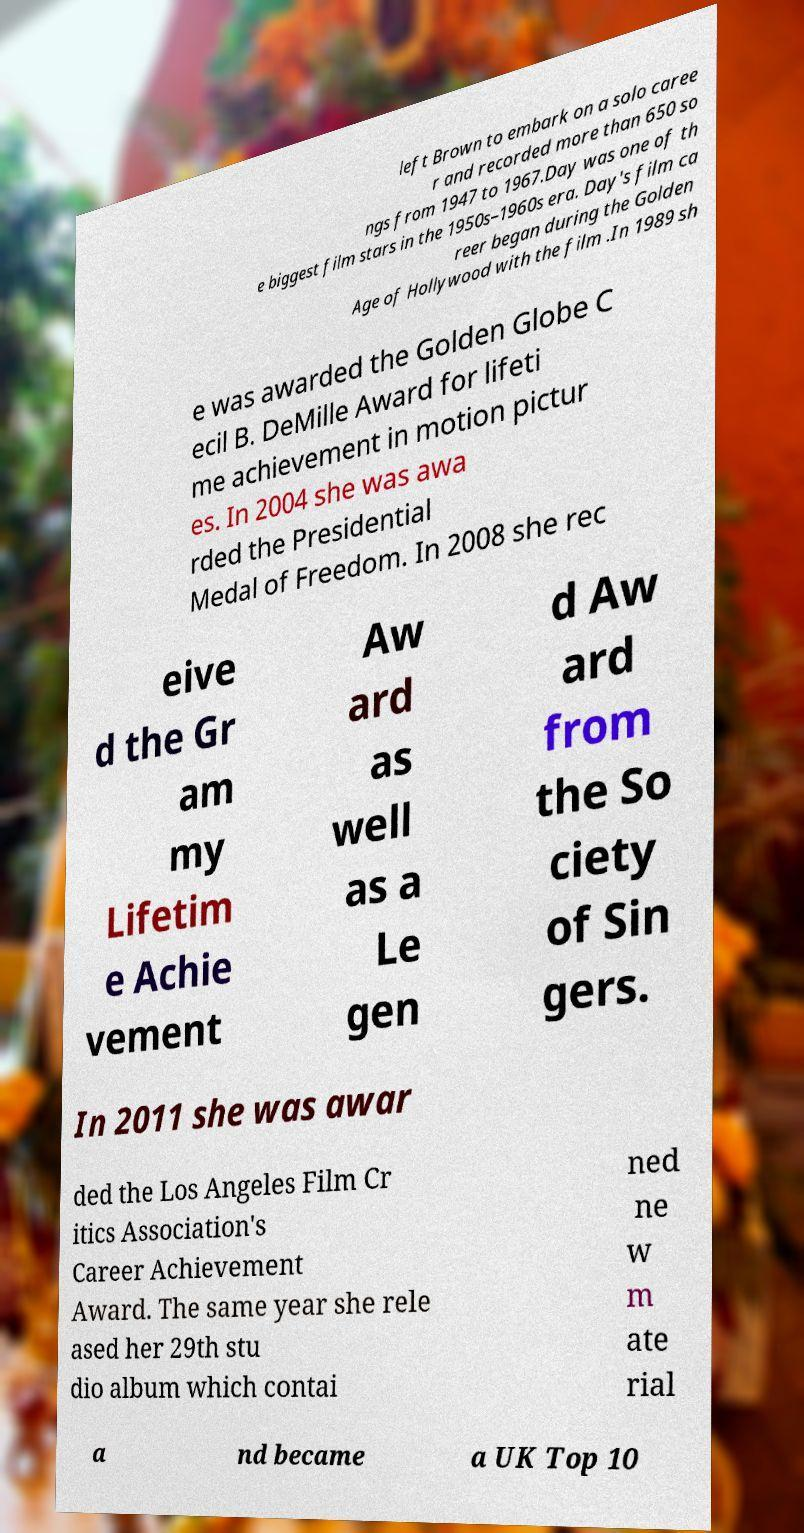Please identify and transcribe the text found in this image. left Brown to embark on a solo caree r and recorded more than 650 so ngs from 1947 to 1967.Day was one of th e biggest film stars in the 1950s–1960s era. Day's film ca reer began during the Golden Age of Hollywood with the film .In 1989 sh e was awarded the Golden Globe C ecil B. DeMille Award for lifeti me achievement in motion pictur es. In 2004 she was awa rded the Presidential Medal of Freedom. In 2008 she rec eive d the Gr am my Lifetim e Achie vement Aw ard as well as a Le gen d Aw ard from the So ciety of Sin gers. In 2011 she was awar ded the Los Angeles Film Cr itics Association's Career Achievement Award. The same year she rele ased her 29th stu dio album which contai ned ne w m ate rial a nd became a UK Top 10 